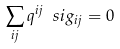Convert formula to latex. <formula><loc_0><loc_0><loc_500><loc_500>\sum _ { i j } q ^ { i j } \ s i g _ { i j } = 0</formula> 